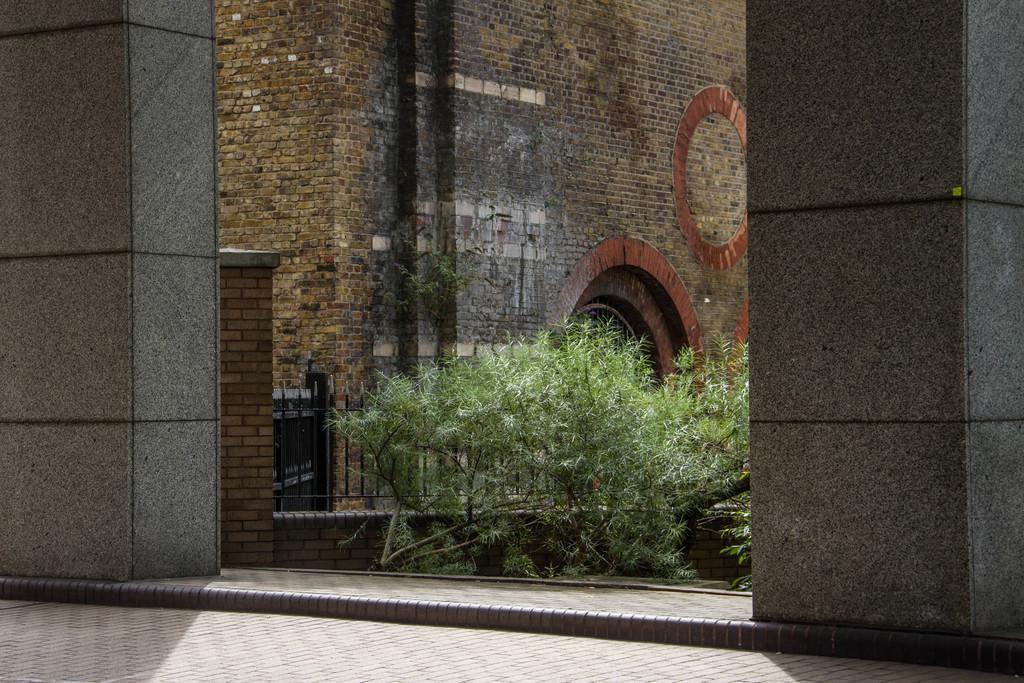Please provide a concise description of this image. In this image we can see a building, in front of the building there are trees, iron railing and pillars. 